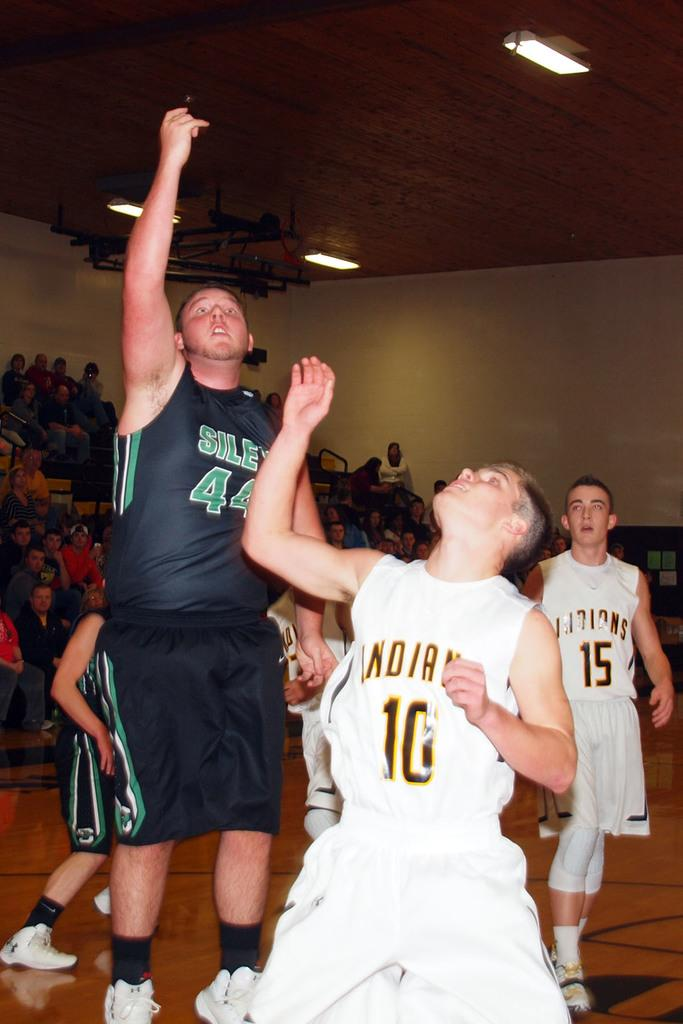<image>
Write a terse but informative summary of the picture. A number 10 is written on the player wearing the white uniform. 